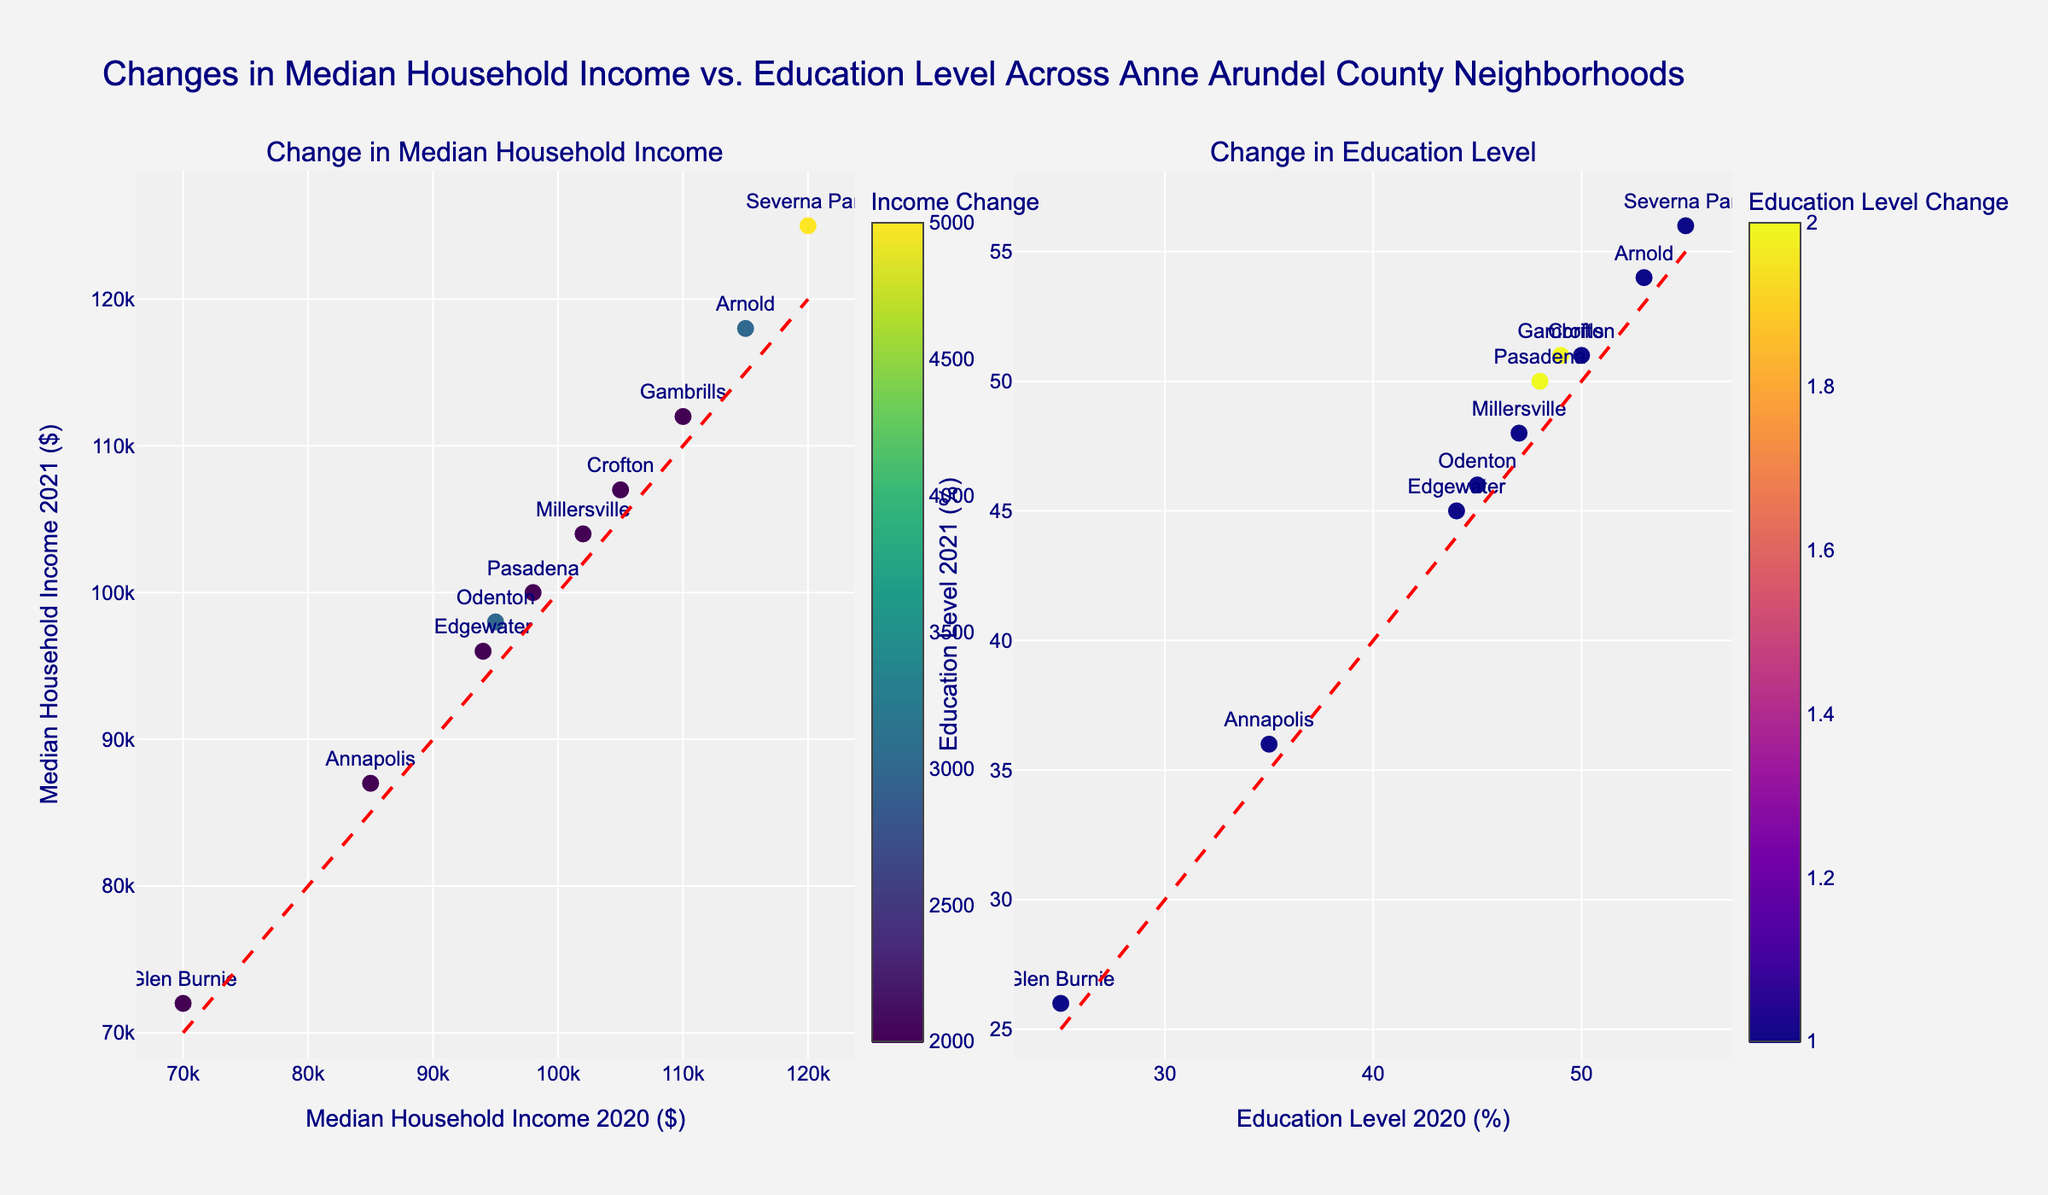What's the title of the plot? The title is prominently displayed at the top of the figure. It reads, "Changes in Median Household Income vs. Education Level Across Anne Arundel County Neighborhoods".
Answer: Changes in Median Household Income vs. Education Level Across Anne Arundel County Neighborhoods How many neighborhoods are represented in the plot? Each marker represents a neighborhood and there are 10 markers on each subplot. By counting these, we can see all 10 neighborhoods are represented in both subplots.
Answer: 10 Which neighborhood had the largest increase in median household income between 2020 and 2021? The color intensity in the income plot indicates the degree of change. The color bar shows the highest change value and by matching this color to the corresponding point, Severna Park shows the largest increase.
Answer: Severna Park What is the change in education level for Pasadena from 2020 to 2021? By reading the hover text on the point labeled Pasadena in the education subplot, we see the difference between the education levels in 2021 and 2020 is calculated: 50% - 48% for Pasadena.
Answer: 2% Which neighborhood had the smallest change in education level? On the education subplot, the color bar indicates the smallest change. By matching this color to the corresponding point, Glen Burnie shows the smallest change in education level.
Answer: Glen Burnie What is the median household income in Odenton for 2021? By hovering on the point labeled "Odenton" in the income subplot, it's visible that the median household income for Odenton in 2021 is $98,000.
Answer: $98,000 Did any neighborhood have a decrease in median household income or education level? Both subplots have diagonal dashed lines indicating no change. All points lie above these lines, meaning all neighborhoods experienced an increase in median household income and education level.
Answer: No What is the correlation trend between the median household incomes of 2020 and 2021? By observing the income subplot, a positive correlation trend is visible because most points align closely above the diagonal line, showing neighborhoods with high income in 2020 also had high incomes in 2021.
Answer: Positive correlation Which neighborhood had an education level above 50% in both 2020 and 2021? By observing the positions of points on both the x and y axes of the education subplot, Severna Park, Crofton, Arnold, and Gambrills had education levels above 50% in both years.
Answer: Severna Park, Crofton, Arnold, Gambrills 